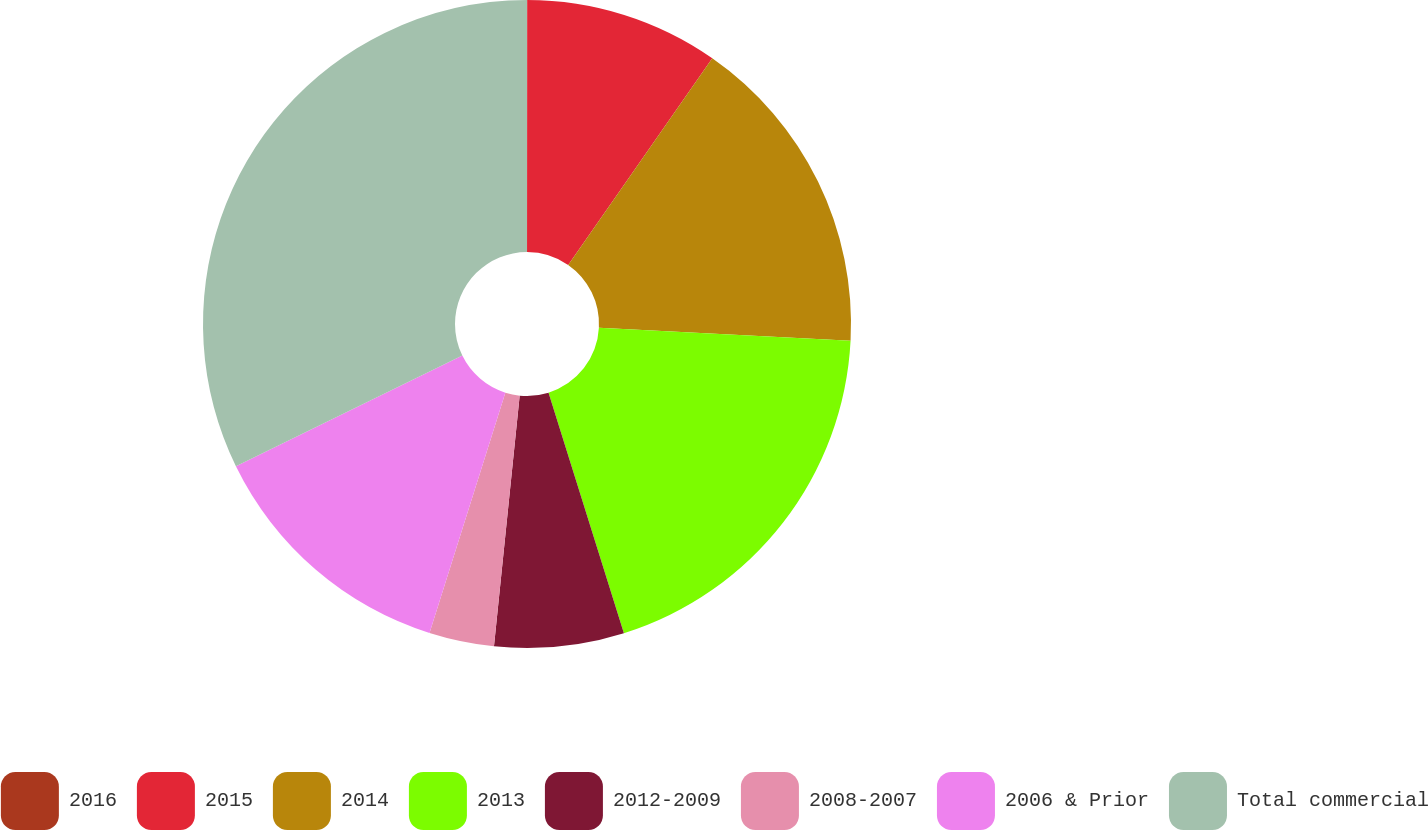Convert chart. <chart><loc_0><loc_0><loc_500><loc_500><pie_chart><fcel>2016<fcel>2015<fcel>2014<fcel>2013<fcel>2012-2009<fcel>2008-2007<fcel>2006 & Prior<fcel>Total commercial<nl><fcel>0.01%<fcel>9.68%<fcel>16.13%<fcel>19.35%<fcel>6.46%<fcel>3.24%<fcel>12.9%<fcel>32.24%<nl></chart> 